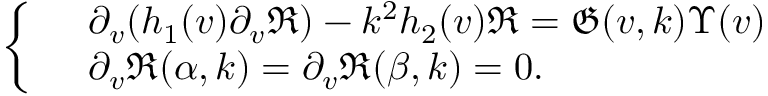<formula> <loc_0><loc_0><loc_500><loc_500>\begin{array} { r } { \left \{ \begin{array} { r l } & { \partial _ { v } ( h _ { 1 } ( v ) \partial _ { v } \mathfrak { R } ) - k ^ { 2 } h _ { 2 } ( v ) \mathfrak { R } = \mathfrak { G } ( v , k ) \Upsilon ( v ) } \\ & { \partial _ { v } \mathfrak { R } ( \alpha , k ) = \partial _ { v } \mathfrak { R } ( \beta , k ) = 0 . } \end{array} } \end{array}</formula> 